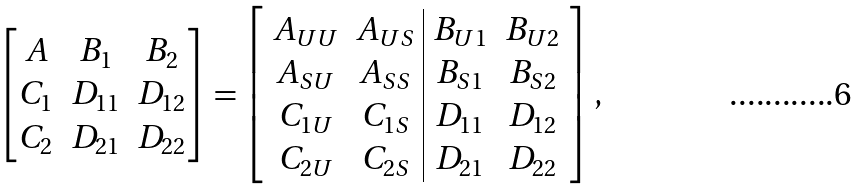Convert formula to latex. <formula><loc_0><loc_0><loc_500><loc_500>\begin{bmatrix} A & B _ { 1 } & B _ { 2 } \\ C _ { 1 } & D _ { 1 1 } & D _ { 1 2 } \\ C _ { 2 } & D _ { 2 1 } & D _ { 2 2 } \end{bmatrix} = \left [ \begin{array} { c c | c c } A _ { U U } & A _ { U S } & B _ { U 1 } & B _ { U 2 } \\ A _ { S U } & A _ { S S } & B _ { S 1 } & B _ { S 2 } \\ C _ { 1 U } & C _ { 1 S } & D _ { 1 1 } & D _ { 1 2 } \\ C _ { 2 U } & C _ { 2 S } & D _ { 2 1 } & D _ { 2 2 } \end{array} \right ] ,</formula> 